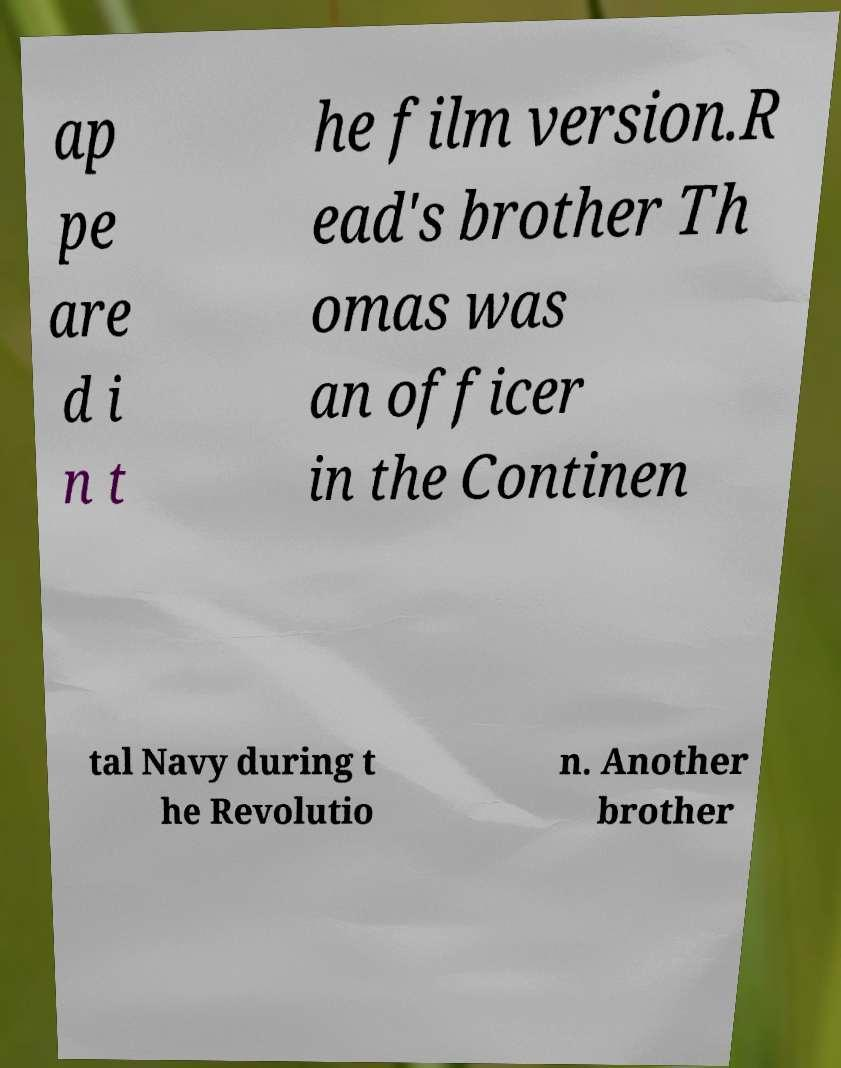I need the written content from this picture converted into text. Can you do that? ap pe are d i n t he film version.R ead's brother Th omas was an officer in the Continen tal Navy during t he Revolutio n. Another brother 